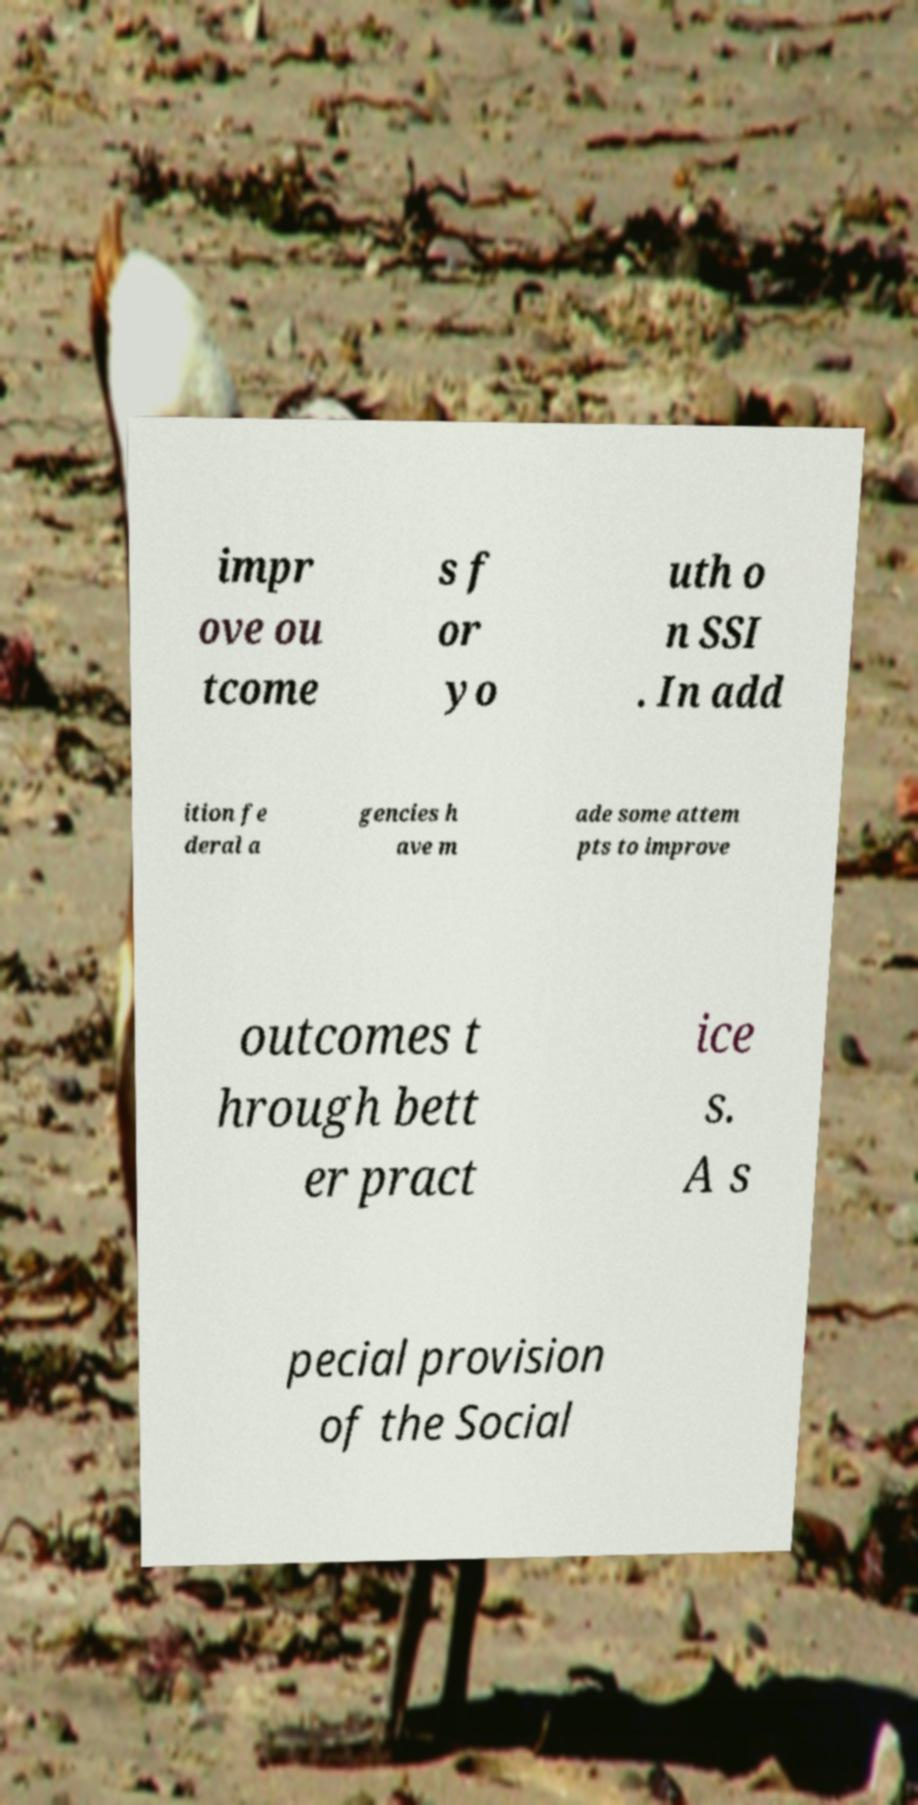Can you accurately transcribe the text from the provided image for me? impr ove ou tcome s f or yo uth o n SSI . In add ition fe deral a gencies h ave m ade some attem pts to improve outcomes t hrough bett er pract ice s. A s pecial provision of the Social 